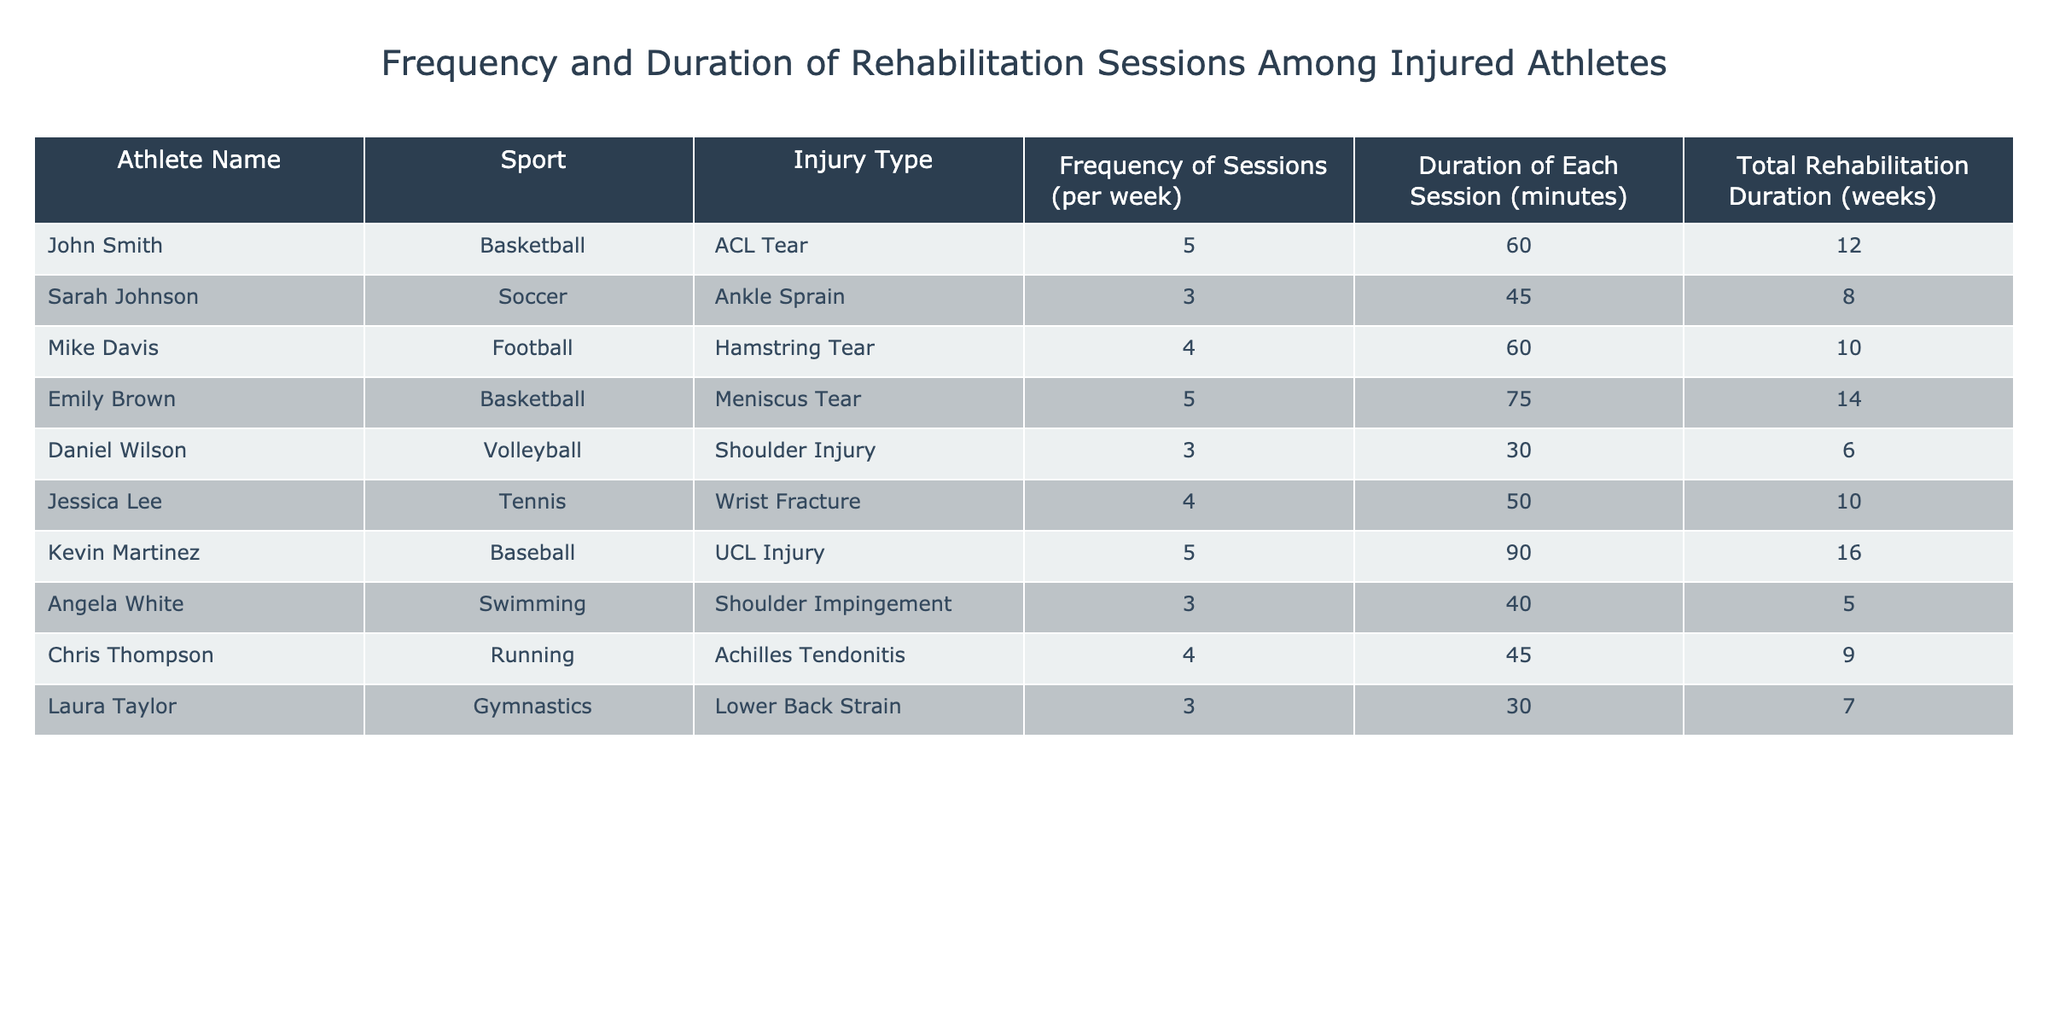What is the frequency of rehabilitation sessions for Emily Brown? Emily Brown is listed in the table under the athlete names with a frequency of 5 sessions per week. The data directly states this information in the corresponding row.
Answer: 5 What sport does Kevin Martinez play? The table specifies that Kevin Martinez plays baseball, as shown in the "Sport" column next to his name.
Answer: Baseball What is the total duration of rehabilitation for Sarah Johnson? According to the table, Sarah Johnson's total rehabilitation duration is listed as 8 weeks. This can be found directly in her row under the "Total Rehabilitation Duration" column.
Answer: 8 weeks How many minutes of rehabilitation does Chris Thompson spend per session? Chris Thompson's data indicates he spends 45 minutes per session, as shown in the "Duration of Each Session" column next to his name.
Answer: 45 minutes What is the average frequency of rehabilitation sessions across all athletes? To calculate the average frequency, we sum up the frequency of each athlete: 5 + 3 + 4 + 5 + 3 + 4 + 5 + 3 + 4 + 3 = 43. There are 10 athletes in total, so we divide 43 by 10, which equals 4.3.
Answer: 4.3 sessions per week Is it true that Angela White has the lowest total rehabilitation duration among the athletes listed? To verify this, we compare Angela White's total rehabilitation duration of 5 weeks with the others. The shortest durations from the table are: John Smith (12), Sarah Johnson (8), Mike Davis (10), Emily Brown (14), Daniel Wilson (6), Jessica Lee (10), Kevin Martinez (16), Chris Thompson (9), and Laura Taylor (7). Angela White has the lowest at 5 weeks, confirming the statement is true.
Answer: Yes Which athlete has the highest total rehabilitation duration and what is it? Upon reviewing the total rehabilitation durations from the table, Kevin Martinez's total rehabilitation duration of 16 weeks is the highest among all athletes. Therefore, he is the athlete with the longest recovery period.
Answer: Kevin Martinez, 16 weeks How many athletes engage in rehabilitation sessions three times a week? In the table, we identify the athletes with a frequency of 3 sessions per week: Sarah Johnson, Daniel Wilson, Angela White, and Laura Taylor. There are 4 such athletes total.
Answer: 4 athletes Which sport has the most number of athletes listed in the table, and how many athletes participate in it? By reviewing the table, we can see that basketball has 2 athletes listed; John Smith and Emily Brown. No other sport has more than this number when counted. Thus, basketball has the most athletes in this dataset.
Answer: Basketball, 2 athletes 